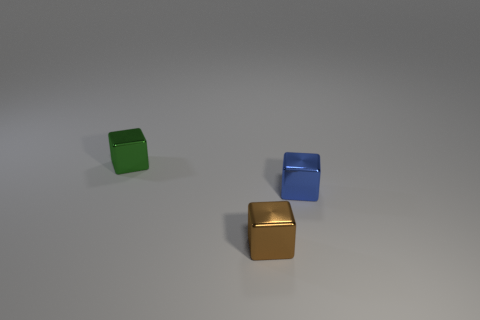Subtract all small blue blocks. How many blocks are left? 2 Add 2 big brown spheres. How many objects exist? 5 Subtract all green blocks. How many blocks are left? 2 Subtract all green cylinders. How many brown blocks are left? 1 Subtract all small metal cubes. Subtract all big blue cylinders. How many objects are left? 0 Add 1 tiny blue cubes. How many tiny blue cubes are left? 2 Add 2 brown blocks. How many brown blocks exist? 3 Subtract 0 green spheres. How many objects are left? 3 Subtract all brown blocks. Subtract all gray spheres. How many blocks are left? 2 